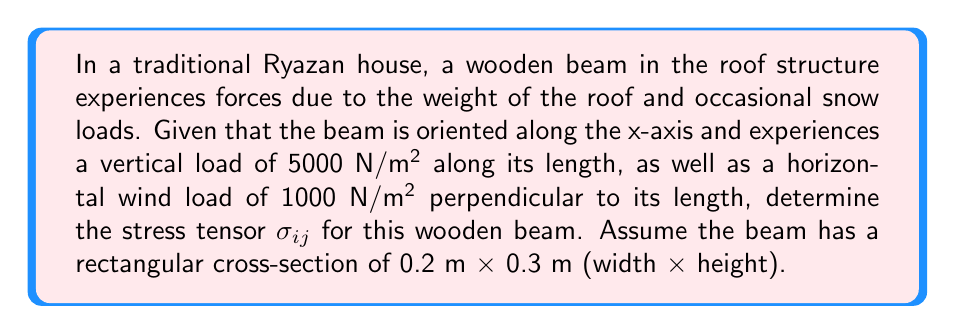Can you answer this question? Let's approach this step-by-step:

1) First, we need to understand the coordinate system. Let's assume:
   x-axis: along the length of the beam
   y-axis: horizontal, perpendicular to the beam
   z-axis: vertical, upward

2) The stress tensor $\sigma_{ij}$ is a 3x3 matrix:

   $$\sigma_{ij} = \begin{pmatrix}
   \sigma_{xx} & \sigma_{xy} & \sigma_{xz} \\
   \sigma_{yx} & \sigma_{yy} & \sigma_{yz} \\
   \sigma_{zx} & \sigma_{zy} & \sigma_{zz}
   \end{pmatrix}$$

3) Calculate the normal stresses:

   $\sigma_{zz} = \frac{F_z}{A} = \frac{5000 \text{ N/m²} \times 0.2 \text{ m}}{0.2 \text{ m} \times 0.3 \text{ m}} = 3333.33 \text{ Pa}$

   $\sigma_{yy} = \frac{F_y}{A} = \frac{1000 \text{ N/m²} \times 0.3 \text{ m}}{0.2 \text{ m} \times 0.3 \text{ m}} = 500 \text{ Pa}$

4) The beam experiences no axial stress along its length, so $\sigma_{xx} = 0$

5) In this simple loading scenario, we can assume there are no shear stresses, so all off-diagonal elements are zero.

6) Therefore, our stress tensor becomes:

   $$\sigma_{ij} = \begin{pmatrix}
   0 & 0 & 0 \\
   0 & 500 & 0 \\
   0 & 0 & 3333.33
   \end{pmatrix} \text{ Pa}$$
Answer: $$\sigma_{ij} = \begin{pmatrix}
0 & 0 & 0 \\
0 & 500 & 0 \\
0 & 0 & 3333.33
\end{pmatrix} \text{ Pa}$$ 